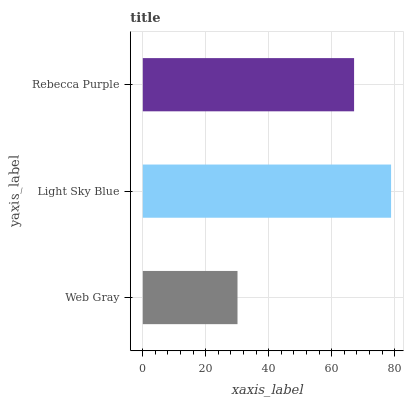Is Web Gray the minimum?
Answer yes or no. Yes. Is Light Sky Blue the maximum?
Answer yes or no. Yes. Is Rebecca Purple the minimum?
Answer yes or no. No. Is Rebecca Purple the maximum?
Answer yes or no. No. Is Light Sky Blue greater than Rebecca Purple?
Answer yes or no. Yes. Is Rebecca Purple less than Light Sky Blue?
Answer yes or no. Yes. Is Rebecca Purple greater than Light Sky Blue?
Answer yes or no. No. Is Light Sky Blue less than Rebecca Purple?
Answer yes or no. No. Is Rebecca Purple the high median?
Answer yes or no. Yes. Is Rebecca Purple the low median?
Answer yes or no. Yes. Is Web Gray the high median?
Answer yes or no. No. Is Light Sky Blue the low median?
Answer yes or no. No. 